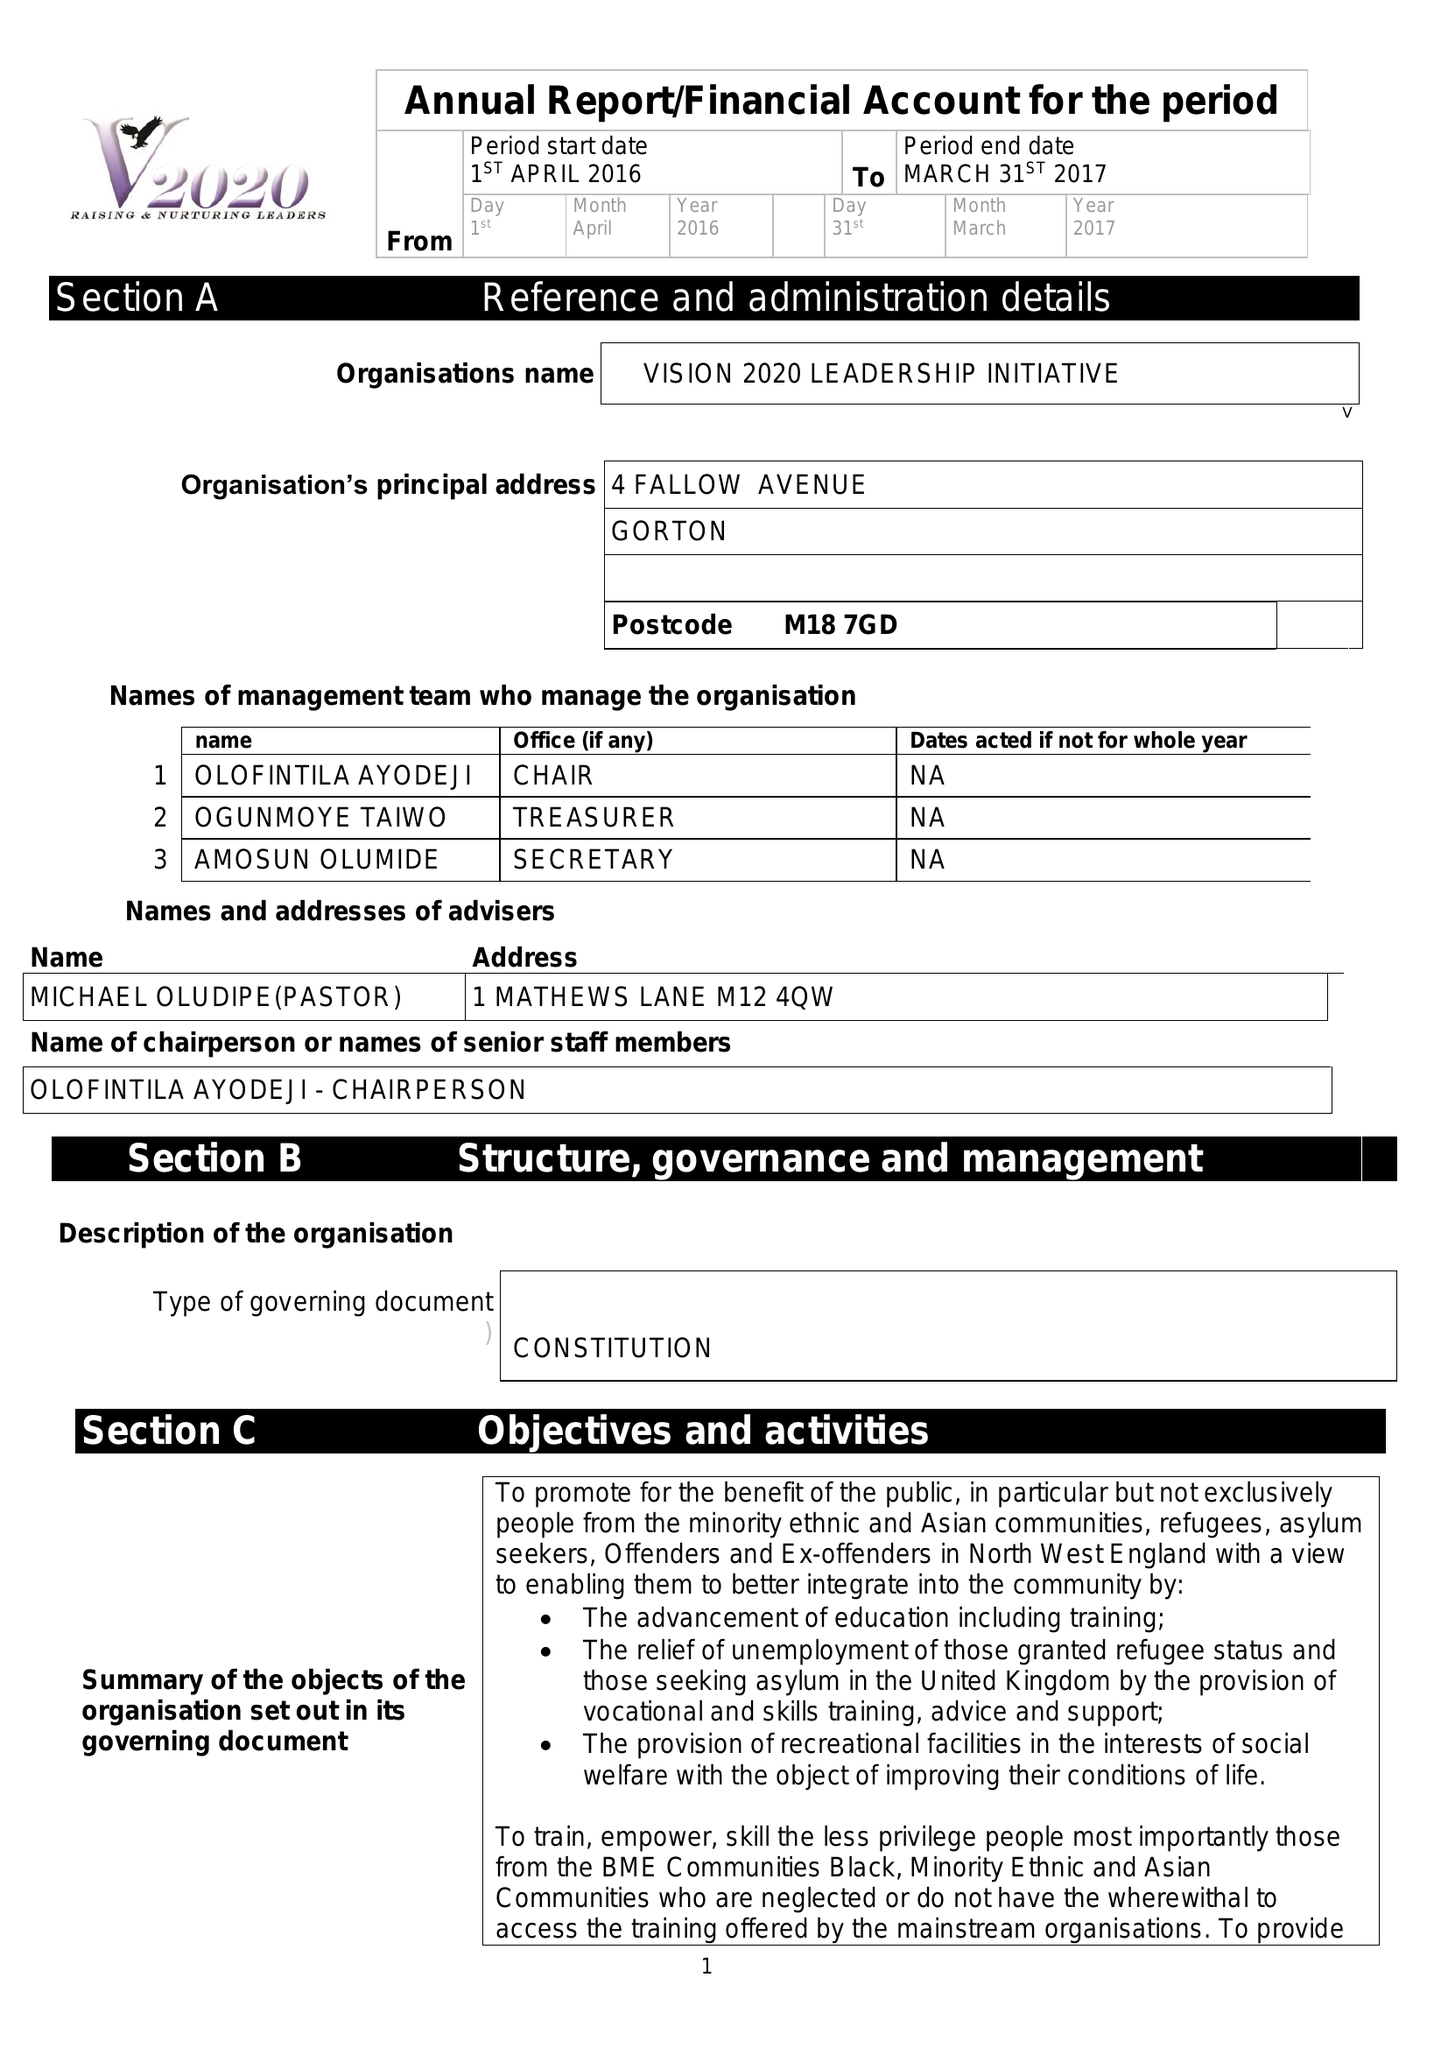What is the value for the report_date?
Answer the question using a single word or phrase. 2017-03-31 